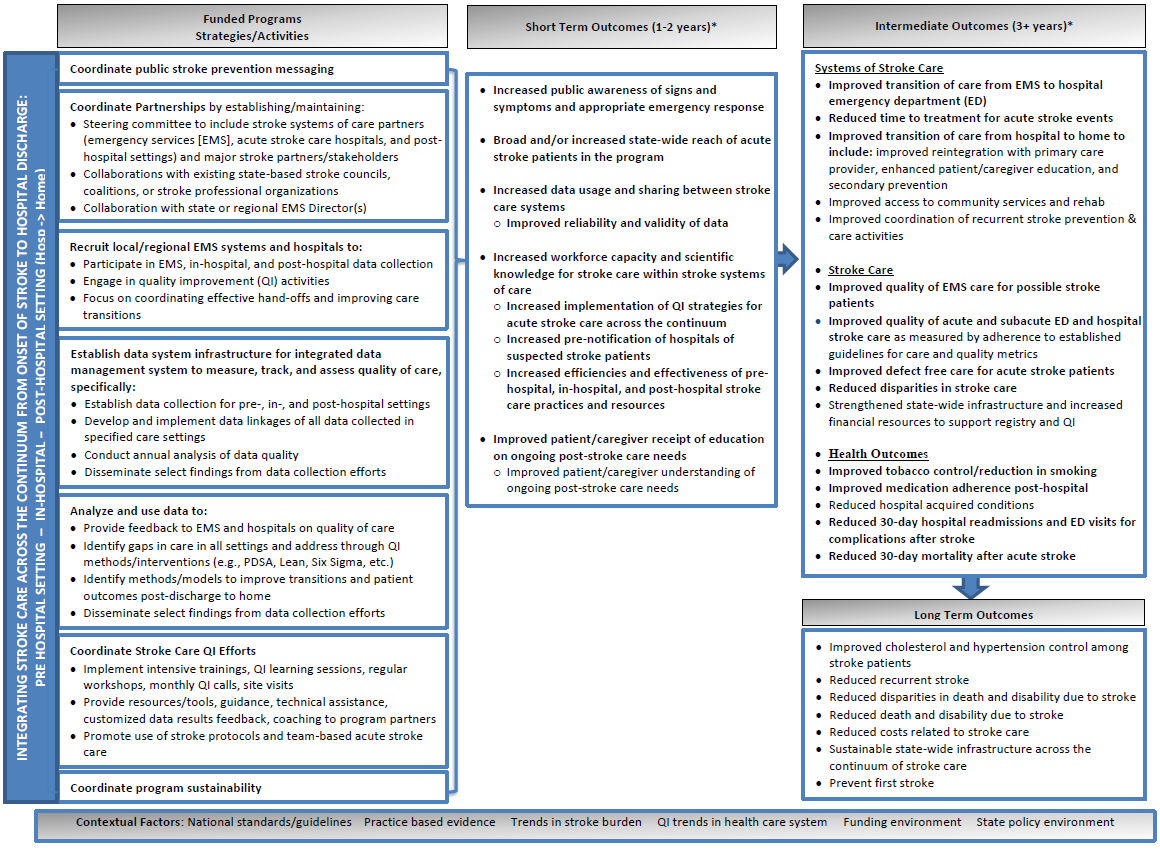Please explain how the integration of real-time data sharing mentioned in the 'Establish data system infrastructure for integrated data management' can enhance short-term outcomes in stroke prevention. Real-time data sharing, as part of an integrated data management system, improves the coordination and efficiency of stroke care by allowing health professionals immediate access to critical patient data. This system supports better decision making in emergency cases and targeted stroke treatments. According to the 'Short Term Outcomes' described, this leads to increased reliability and validity of data, enhancing workforce capacity, and fostering more informed implementation of stroke care protocols. Overall, it expedites the treatment process, reduces the onset of complications, and enhances patient education on stroke prevention. 